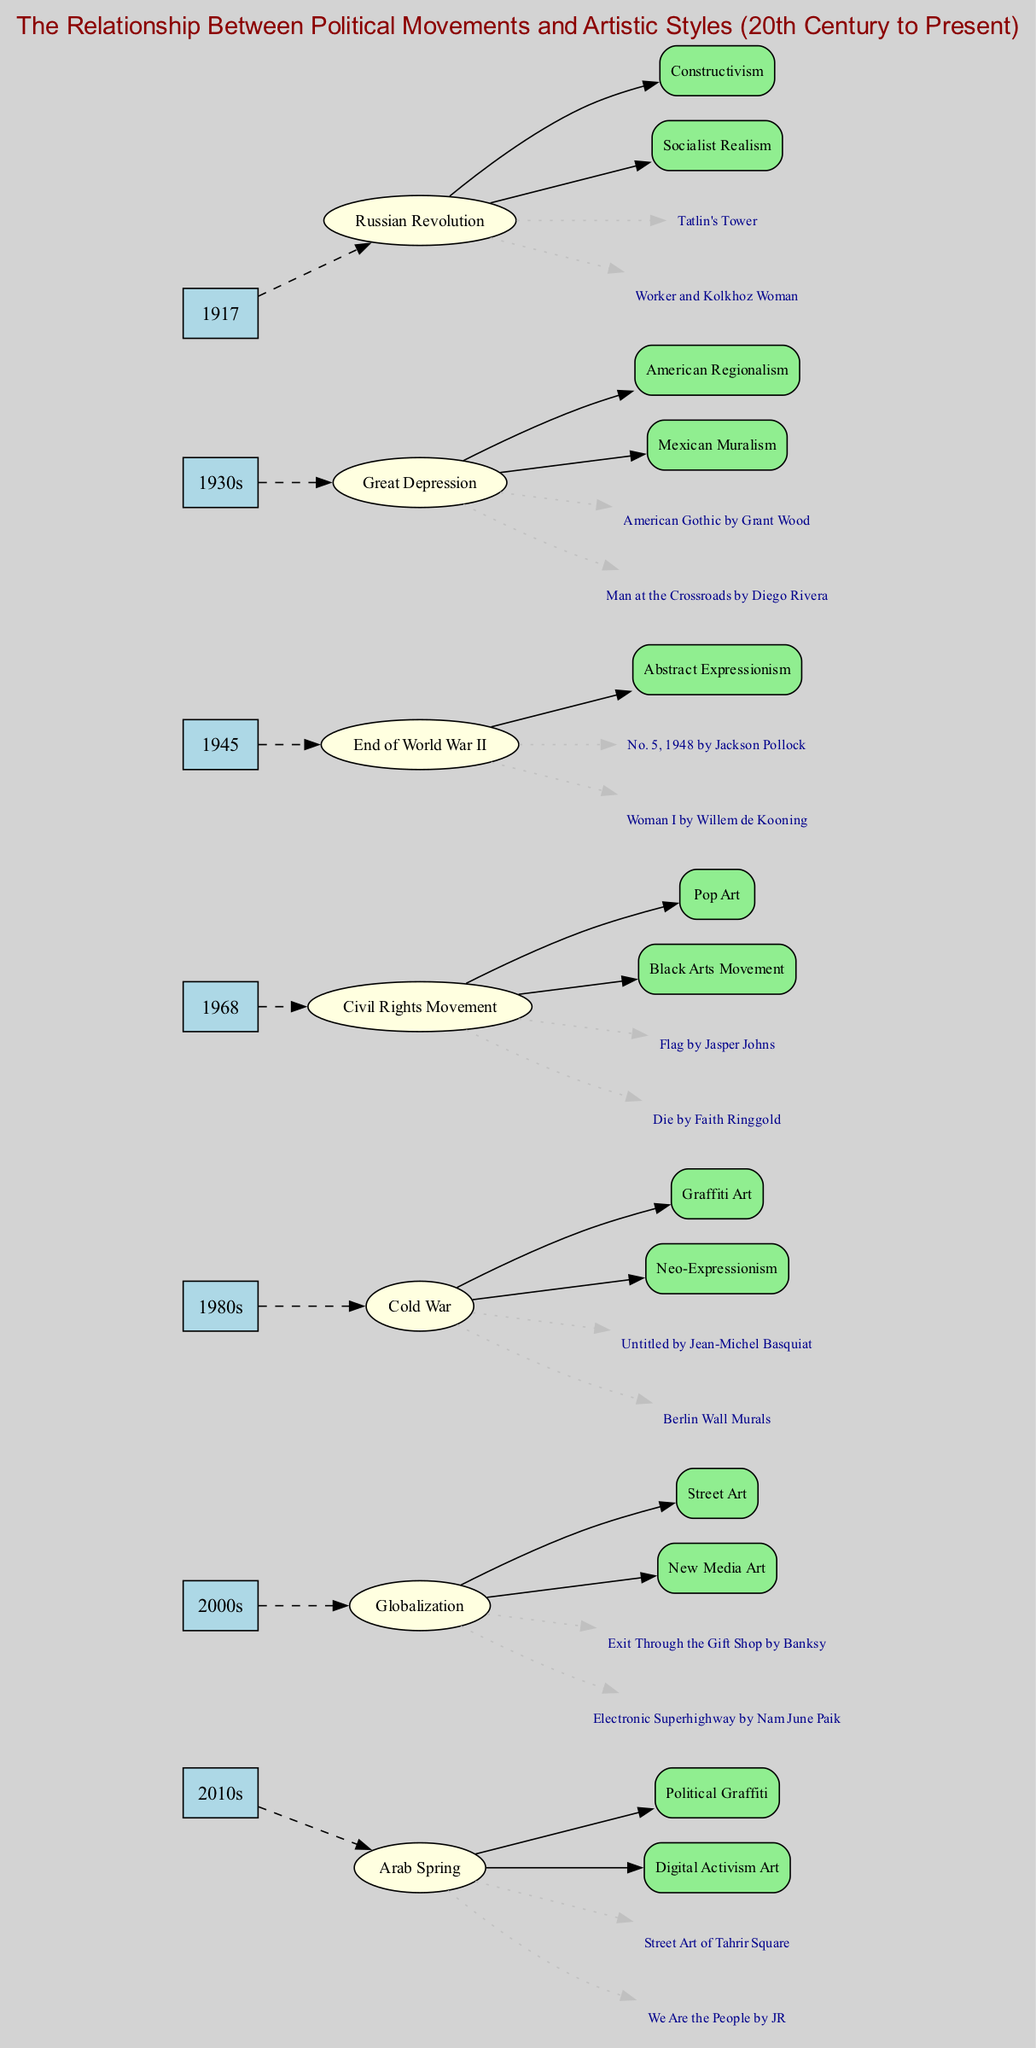What event corresponds to the year 1917? The diagram directly links the year 1917 to the event "Russian Revolution." You can trace the year node to the event, which is clearly labeled.
Answer: Russian Revolution How many art styles are associated with the year 1968? For the year 1968, there are two art styles listed: "Pop Art" and "Black Arts Movement." These can be counted directly from the nodes connected to the event of that year.
Answer: 2 What key artwork is linked to the Great Depression in the 1930s? Looking at the timeline, the Great Depression event has two key artworks listed: "American Gothic by Grant Wood" and "Man at the Crossroads by Diego Rivera." Both artworks are explicitly connected to that event.
Answer: American Gothic by Grant Wood Which artistic style emerged after the end of World War II? The diagram shows that after the end of World War II in 1945, the artistic style "Abstract Expressionism" is linked to this event. This can be seen directly through the connections from the event node.
Answer: Abstract Expressionism What is one key artwork from the 2010s related to political activism? In the 2010s, the diagram highlights "Street Art of Tahrir Square" as a key artwork associated with the Arab Spring. This connection can be traced from the event node for that year.
Answer: Street Art of Tahrir Square How are the artistic styles from the 1980s characterized? The 1980s are characterized by two artistic styles, specifically "Graffiti Art" and "Neo-Expressionism," showing clear connections to the event of that decade. You can identify these from the respective nodes in the diagram.
Answer: Graffiti Art, Neo-Expressionism What connects the Civil Rights Movement to its corresponding artworks? The Civil Rights Movement in 1968 is connected to key artworks like "Flag by Jasper Johns" and "Die by Faith Ringgold." These relationships can be discerned by following the edges from the event to the artworks.
Answer: Flag by Jasper Johns, Die by Faith Ringgold Which decade is associated with the event 'Globalization'? The event 'Globalization' is categorized under the 2000s in the timeline. This is established by directly observing the year linked to that particular event node in the diagram.
Answer: 2000s In what way do the art movements change according to the political climate? The diagram shows that various political movements directly influence the emergence of distinct artistic styles, like how the Russian Revolution led to Constructivism and Socialist Realism. This indicates a pattern of art reflecting political sentiment throughout the timeline.
Answer: Art reflects political sentiment 